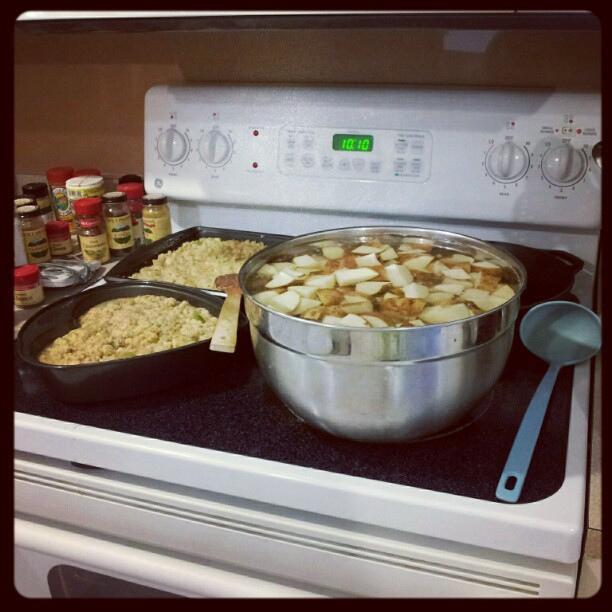Storing the items in the water prevents them from what?
Select the accurate response from the four choices given to answer the question.
Options: Changing color, gathering bacteria, harboring flies, losing flavor. Changing color. 